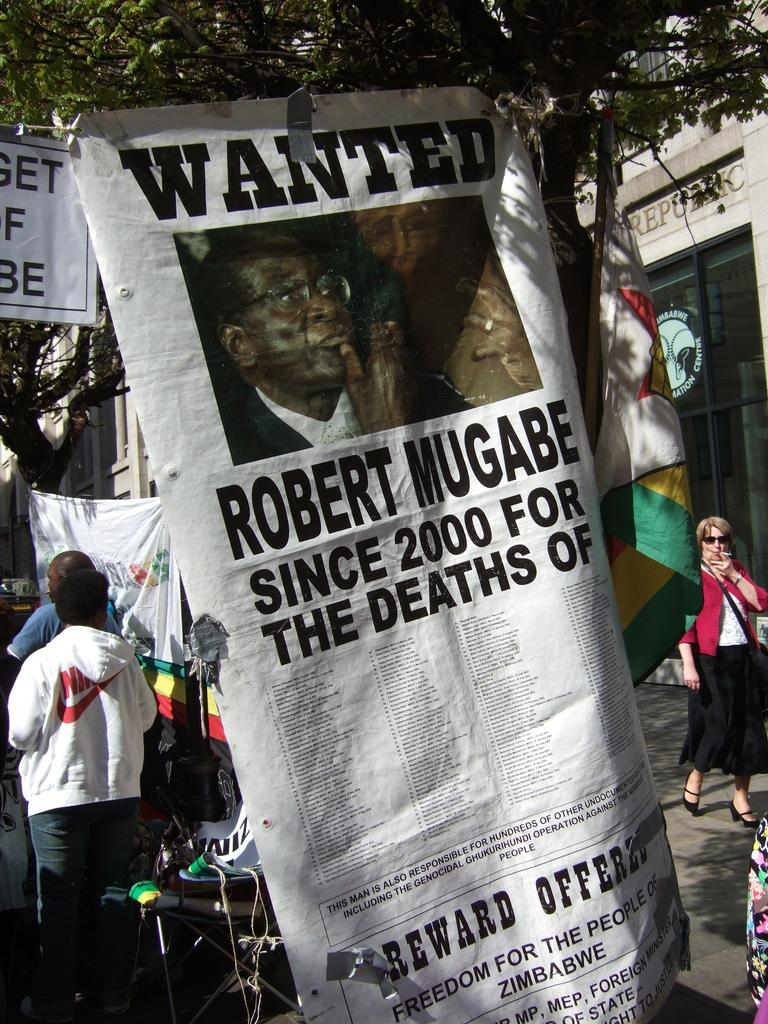What is the main subject of the image? The main subject of the image is a wanted poster. How is the wanted poster displayed? The wanted poster is attached to a tree. Are there any people in the image? Yes, there are people around the wanted poster. What else can be seen in the image besides the wanted poster and people? There are flags and a building on the right side of the image. What type of ornament is hanging from the wanted poster? There is no ornament hanging from the wanted poster in the image. How does the image promote peace? The image does not specifically promote peace; it features a wanted poster and people around it. 